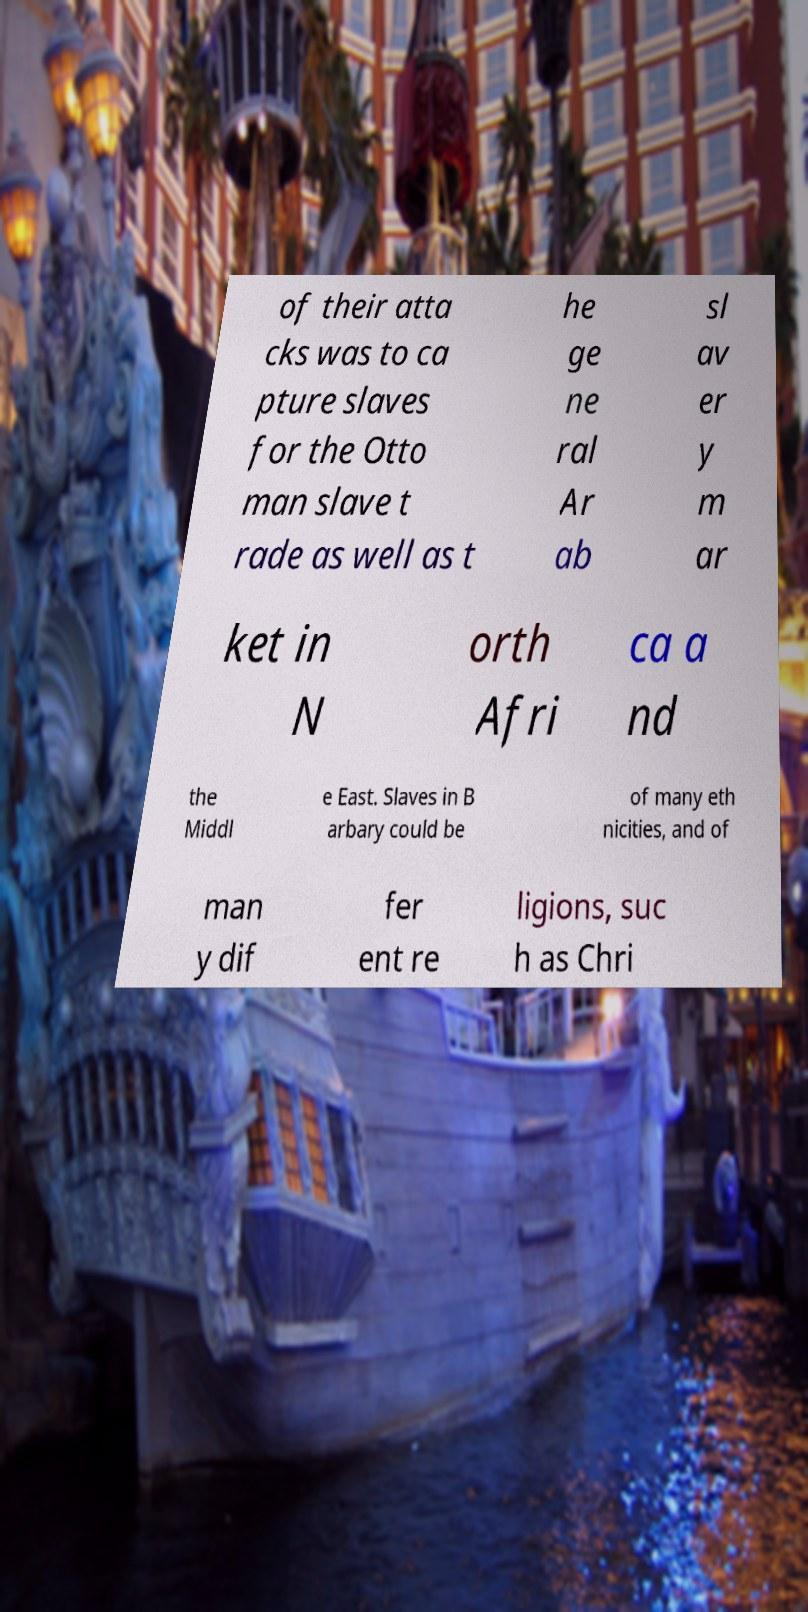There's text embedded in this image that I need extracted. Can you transcribe it verbatim? of their atta cks was to ca pture slaves for the Otto man slave t rade as well as t he ge ne ral Ar ab sl av er y m ar ket in N orth Afri ca a nd the Middl e East. Slaves in B arbary could be of many eth nicities, and of man y dif fer ent re ligions, suc h as Chri 